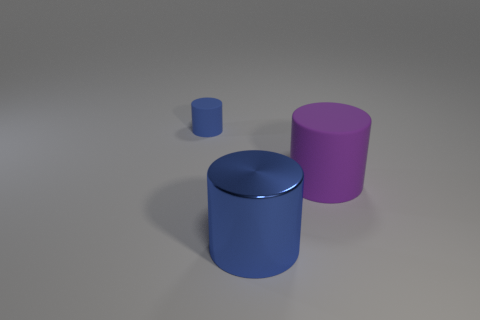Subtract all gray cylinders. Subtract all brown cubes. How many cylinders are left? 3 Add 2 big purple rubber objects. How many objects exist? 5 Subtract 0 gray balls. How many objects are left? 3 Subtract all small blue rubber objects. Subtract all big blue shiny objects. How many objects are left? 1 Add 1 big purple things. How many big purple things are left? 2 Add 2 gray matte spheres. How many gray matte spheres exist? 2 